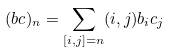<formula> <loc_0><loc_0><loc_500><loc_500>( { b c } ) _ { n } = \sum _ { [ i , j ] = n } ( i , j ) b _ { i } c _ { j }</formula> 